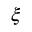<formula> <loc_0><loc_0><loc_500><loc_500>\xi</formula> 